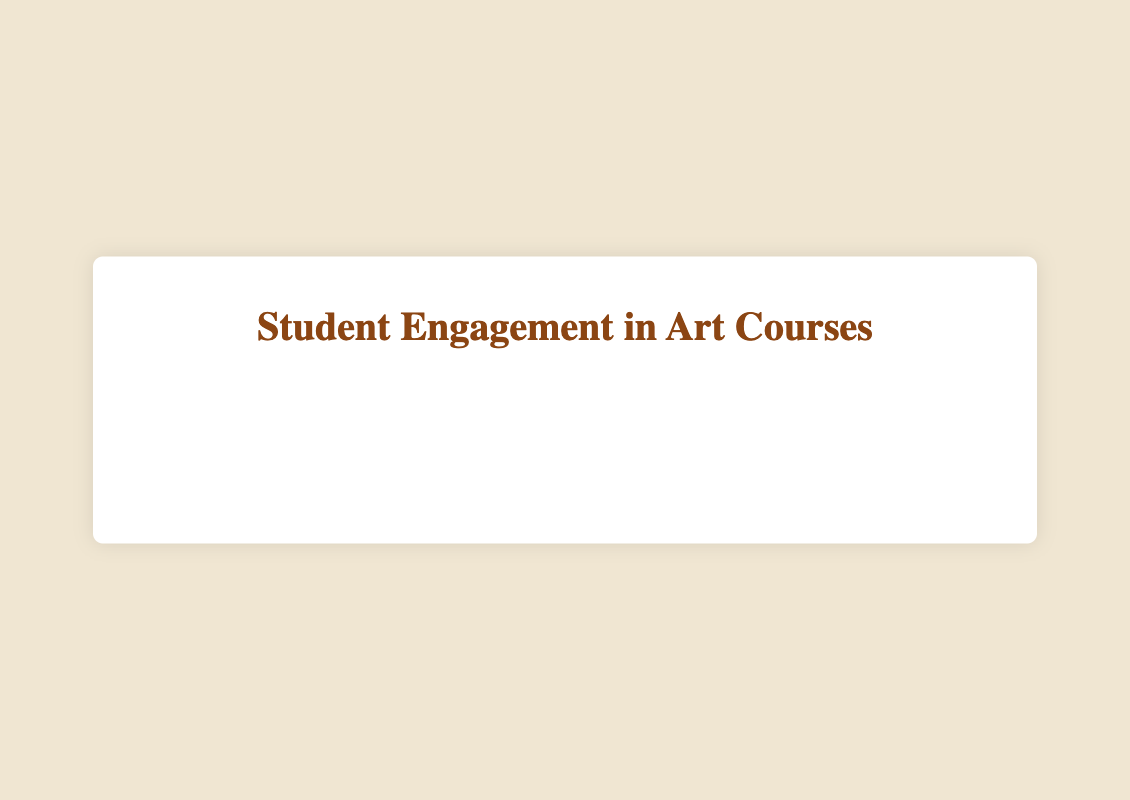What is the title of the chart? The title is displayed at the top of the chart.
Answer: Student Engagement by Course, Year, and Major What is the range of years represented in the chart? The x-axis represents the years, ranging from 2019.5 to 2022.5, covering the years 2020 to 2022.
Answer: 2020 to 2022 How many courses are represented in the year 2022? There are three data points along the x-axis at 2022.
Answer: 3 Which course had the highest engagement level? Look for the highest y-coordinate value across all bubbles.
Answer: Contemporary Art Compare the engagement levels of Art History courses in 2020. Which one had higher engagement? Identify the bubbles in 2020 marked with red color (Art History major) and compare their y-values.
Answer: Renaissance Art What's the average engagement level for Fine Arts courses? There are three Fine Arts data points: Sculpture Techniques (78), Painting Methods (80), Digital Art (87). Calculate the average: (78 + 80 + 87) / 3 = 81.67.
Answer: 81.67 Which course had the largest number of students enrolled in 2022, and what was its engagement level? Look at the bubble sizes in 2022; the largest bubble has the highest number of students. Match this with the y-coordinate for its engagement level.
Answer: Contemporary Art, 92 What is the difference in engagement levels between the Art History and Fine Arts courses in 2021? Locate the Art History and Fine Arts bubbles in 2021. The engagement levels are 82 (Baroque Art) and 80 (Painting Methods). Calculate the difference: 82 - 80.
Answer: 2 How does the engagement level of Digital Art in 2022 compare to that of Typography? Both bubbles are in 2022 but Digital Art is Fine Arts, and Typography is Graphic Design. Digital Art has an engagement of 87 while Typography has 79.
Answer: Digital Art is higher by 8 Calculate the total number of students enrolled in Art History courses in 2020. Sum the student enrollments of Art History courses in 2020: Renaissance Art (45) and Modern Art (40). Total is 45 + 40.
Answer: 85 